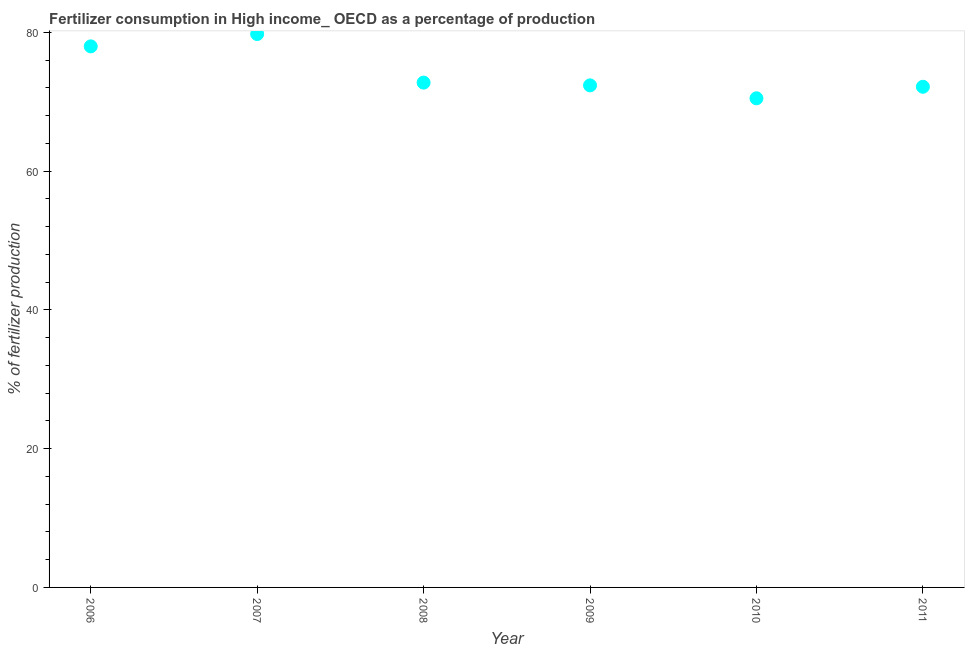What is the amount of fertilizer consumption in 2010?
Offer a terse response. 70.5. Across all years, what is the maximum amount of fertilizer consumption?
Provide a short and direct response. 79.76. Across all years, what is the minimum amount of fertilizer consumption?
Give a very brief answer. 70.5. In which year was the amount of fertilizer consumption maximum?
Keep it short and to the point. 2007. In which year was the amount of fertilizer consumption minimum?
Provide a short and direct response. 2010. What is the sum of the amount of fertilizer consumption?
Offer a terse response. 445.52. What is the difference between the amount of fertilizer consumption in 2009 and 2011?
Provide a succinct answer. 0.2. What is the average amount of fertilizer consumption per year?
Your answer should be very brief. 74.25. What is the median amount of fertilizer consumption?
Give a very brief answer. 72.56. Do a majority of the years between 2009 and 2007 (inclusive) have amount of fertilizer consumption greater than 8 %?
Offer a terse response. No. What is the ratio of the amount of fertilizer consumption in 2006 to that in 2007?
Your answer should be very brief. 0.98. Is the difference between the amount of fertilizer consumption in 2006 and 2010 greater than the difference between any two years?
Ensure brevity in your answer.  No. What is the difference between the highest and the second highest amount of fertilizer consumption?
Your answer should be compact. 1.78. What is the difference between the highest and the lowest amount of fertilizer consumption?
Your response must be concise. 9.26. Does the amount of fertilizer consumption monotonically increase over the years?
Provide a short and direct response. No. How many dotlines are there?
Keep it short and to the point. 1. How many years are there in the graph?
Your answer should be very brief. 6. What is the difference between two consecutive major ticks on the Y-axis?
Your answer should be compact. 20. Does the graph contain any zero values?
Your answer should be compact. No. What is the title of the graph?
Your answer should be compact. Fertilizer consumption in High income_ OECD as a percentage of production. What is the label or title of the Y-axis?
Offer a very short reply. % of fertilizer production. What is the % of fertilizer production in 2006?
Your answer should be very brief. 77.98. What is the % of fertilizer production in 2007?
Your answer should be very brief. 79.76. What is the % of fertilizer production in 2008?
Offer a terse response. 72.76. What is the % of fertilizer production in 2009?
Offer a terse response. 72.36. What is the % of fertilizer production in 2010?
Your answer should be very brief. 70.5. What is the % of fertilizer production in 2011?
Provide a short and direct response. 72.16. What is the difference between the % of fertilizer production in 2006 and 2007?
Provide a succinct answer. -1.78. What is the difference between the % of fertilizer production in 2006 and 2008?
Provide a succinct answer. 5.23. What is the difference between the % of fertilizer production in 2006 and 2009?
Provide a short and direct response. 5.62. What is the difference between the % of fertilizer production in 2006 and 2010?
Your answer should be compact. 7.49. What is the difference between the % of fertilizer production in 2006 and 2011?
Give a very brief answer. 5.82. What is the difference between the % of fertilizer production in 2007 and 2008?
Provide a short and direct response. 7. What is the difference between the % of fertilizer production in 2007 and 2009?
Provide a succinct answer. 7.4. What is the difference between the % of fertilizer production in 2007 and 2010?
Give a very brief answer. 9.26. What is the difference between the % of fertilizer production in 2007 and 2011?
Offer a terse response. 7.6. What is the difference between the % of fertilizer production in 2008 and 2009?
Provide a short and direct response. 0.4. What is the difference between the % of fertilizer production in 2008 and 2010?
Offer a terse response. 2.26. What is the difference between the % of fertilizer production in 2008 and 2011?
Offer a very short reply. 0.6. What is the difference between the % of fertilizer production in 2009 and 2010?
Give a very brief answer. 1.86. What is the difference between the % of fertilizer production in 2009 and 2011?
Provide a succinct answer. 0.2. What is the difference between the % of fertilizer production in 2010 and 2011?
Provide a succinct answer. -1.66. What is the ratio of the % of fertilizer production in 2006 to that in 2007?
Keep it short and to the point. 0.98. What is the ratio of the % of fertilizer production in 2006 to that in 2008?
Keep it short and to the point. 1.07. What is the ratio of the % of fertilizer production in 2006 to that in 2009?
Your answer should be very brief. 1.08. What is the ratio of the % of fertilizer production in 2006 to that in 2010?
Offer a very short reply. 1.11. What is the ratio of the % of fertilizer production in 2006 to that in 2011?
Ensure brevity in your answer.  1.08. What is the ratio of the % of fertilizer production in 2007 to that in 2008?
Give a very brief answer. 1.1. What is the ratio of the % of fertilizer production in 2007 to that in 2009?
Make the answer very short. 1.1. What is the ratio of the % of fertilizer production in 2007 to that in 2010?
Ensure brevity in your answer.  1.13. What is the ratio of the % of fertilizer production in 2007 to that in 2011?
Offer a very short reply. 1.1. What is the ratio of the % of fertilizer production in 2008 to that in 2009?
Provide a succinct answer. 1. What is the ratio of the % of fertilizer production in 2008 to that in 2010?
Keep it short and to the point. 1.03. What is the ratio of the % of fertilizer production in 2008 to that in 2011?
Provide a succinct answer. 1.01. What is the ratio of the % of fertilizer production in 2009 to that in 2010?
Offer a very short reply. 1.03. What is the ratio of the % of fertilizer production in 2009 to that in 2011?
Your response must be concise. 1. What is the ratio of the % of fertilizer production in 2010 to that in 2011?
Your response must be concise. 0.98. 